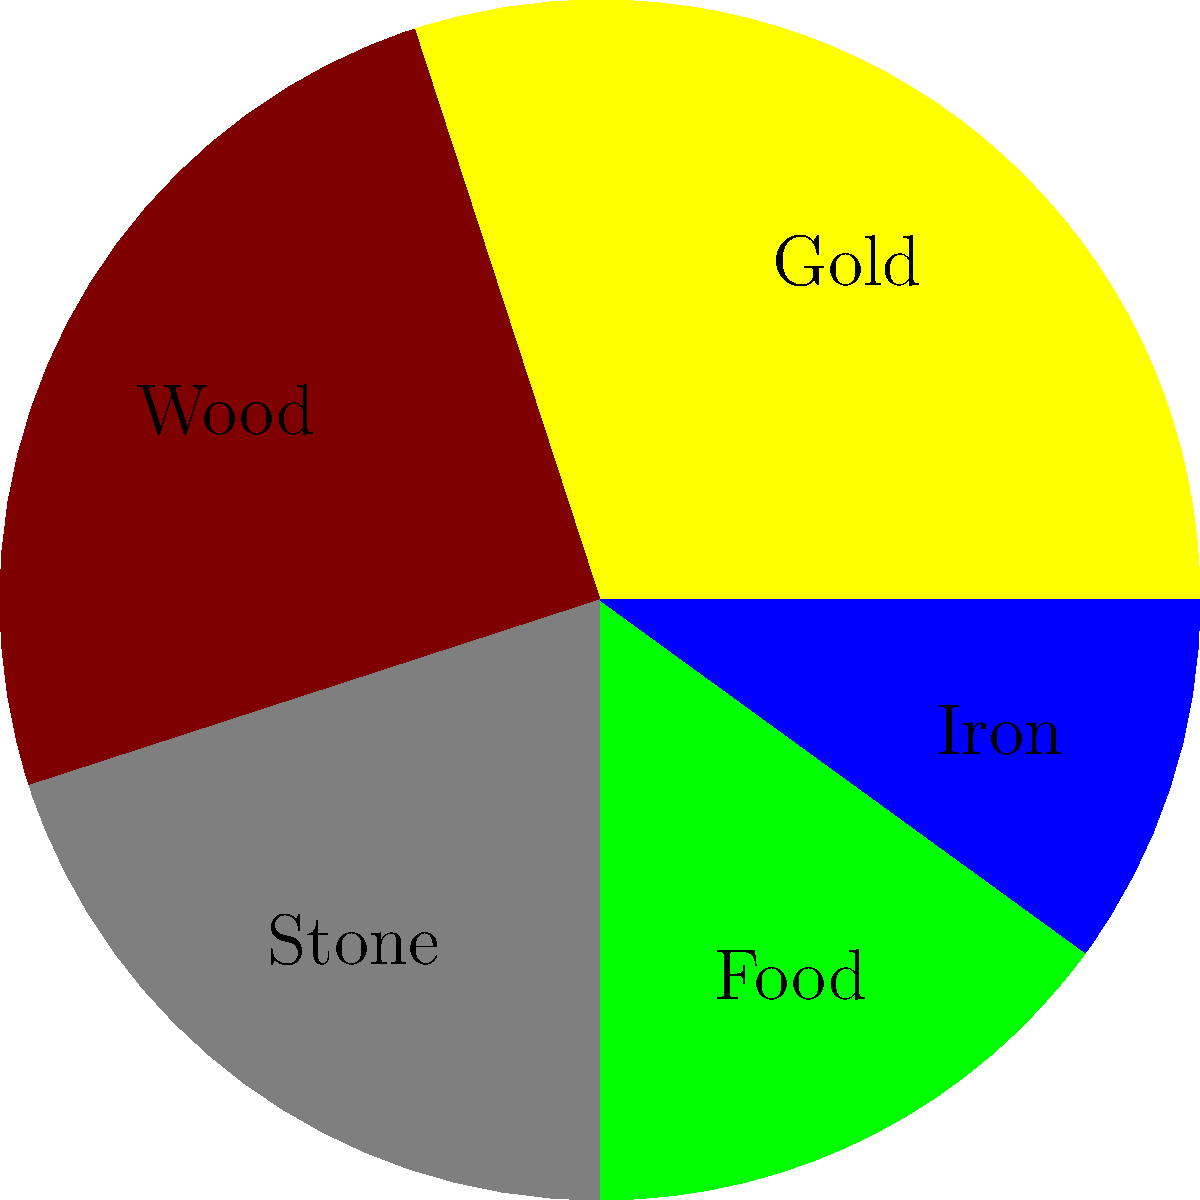In our strategy game, we need to balance resource distribution. The pie chart shows the current allocation of resources. If we want to increase the "Food" sector by 5 percentage points while maintaining the same ratio between all other resources, what would be the new percentage for "Wood"? Let's approach this step-by-step:

1. Current percentages:
   Gold: 30%, Wood: 25%, Stone: 20%, Food: 15%, Iron: 10%

2. We need to increase Food by 5 percentage points:
   New Food percentage = 15% + 5% = 20%

3. The remaining 80% needs to be distributed among the other resources while maintaining their ratio:
   Total of other resources: 30% + 25% + 20% + 10% = 85%

4. To maintain the ratio, we need to multiply each resource by a factor:
   Factor = (100% - 20%) / 85% = 80% / 85% ≈ 0.9412

5. New percentages for other resources:
   Gold: 30% * 0.9412 ≈ 28.24%
   Wood: 25% * 0.9412 ≈ 23.53%
   Stone: 20% * 0.9412 ≈ 18.82%
   Iron: 10% * 0.9412 ≈ 9.41%

6. The new percentage for Wood is approximately 23.53%
Answer: 23.53% 